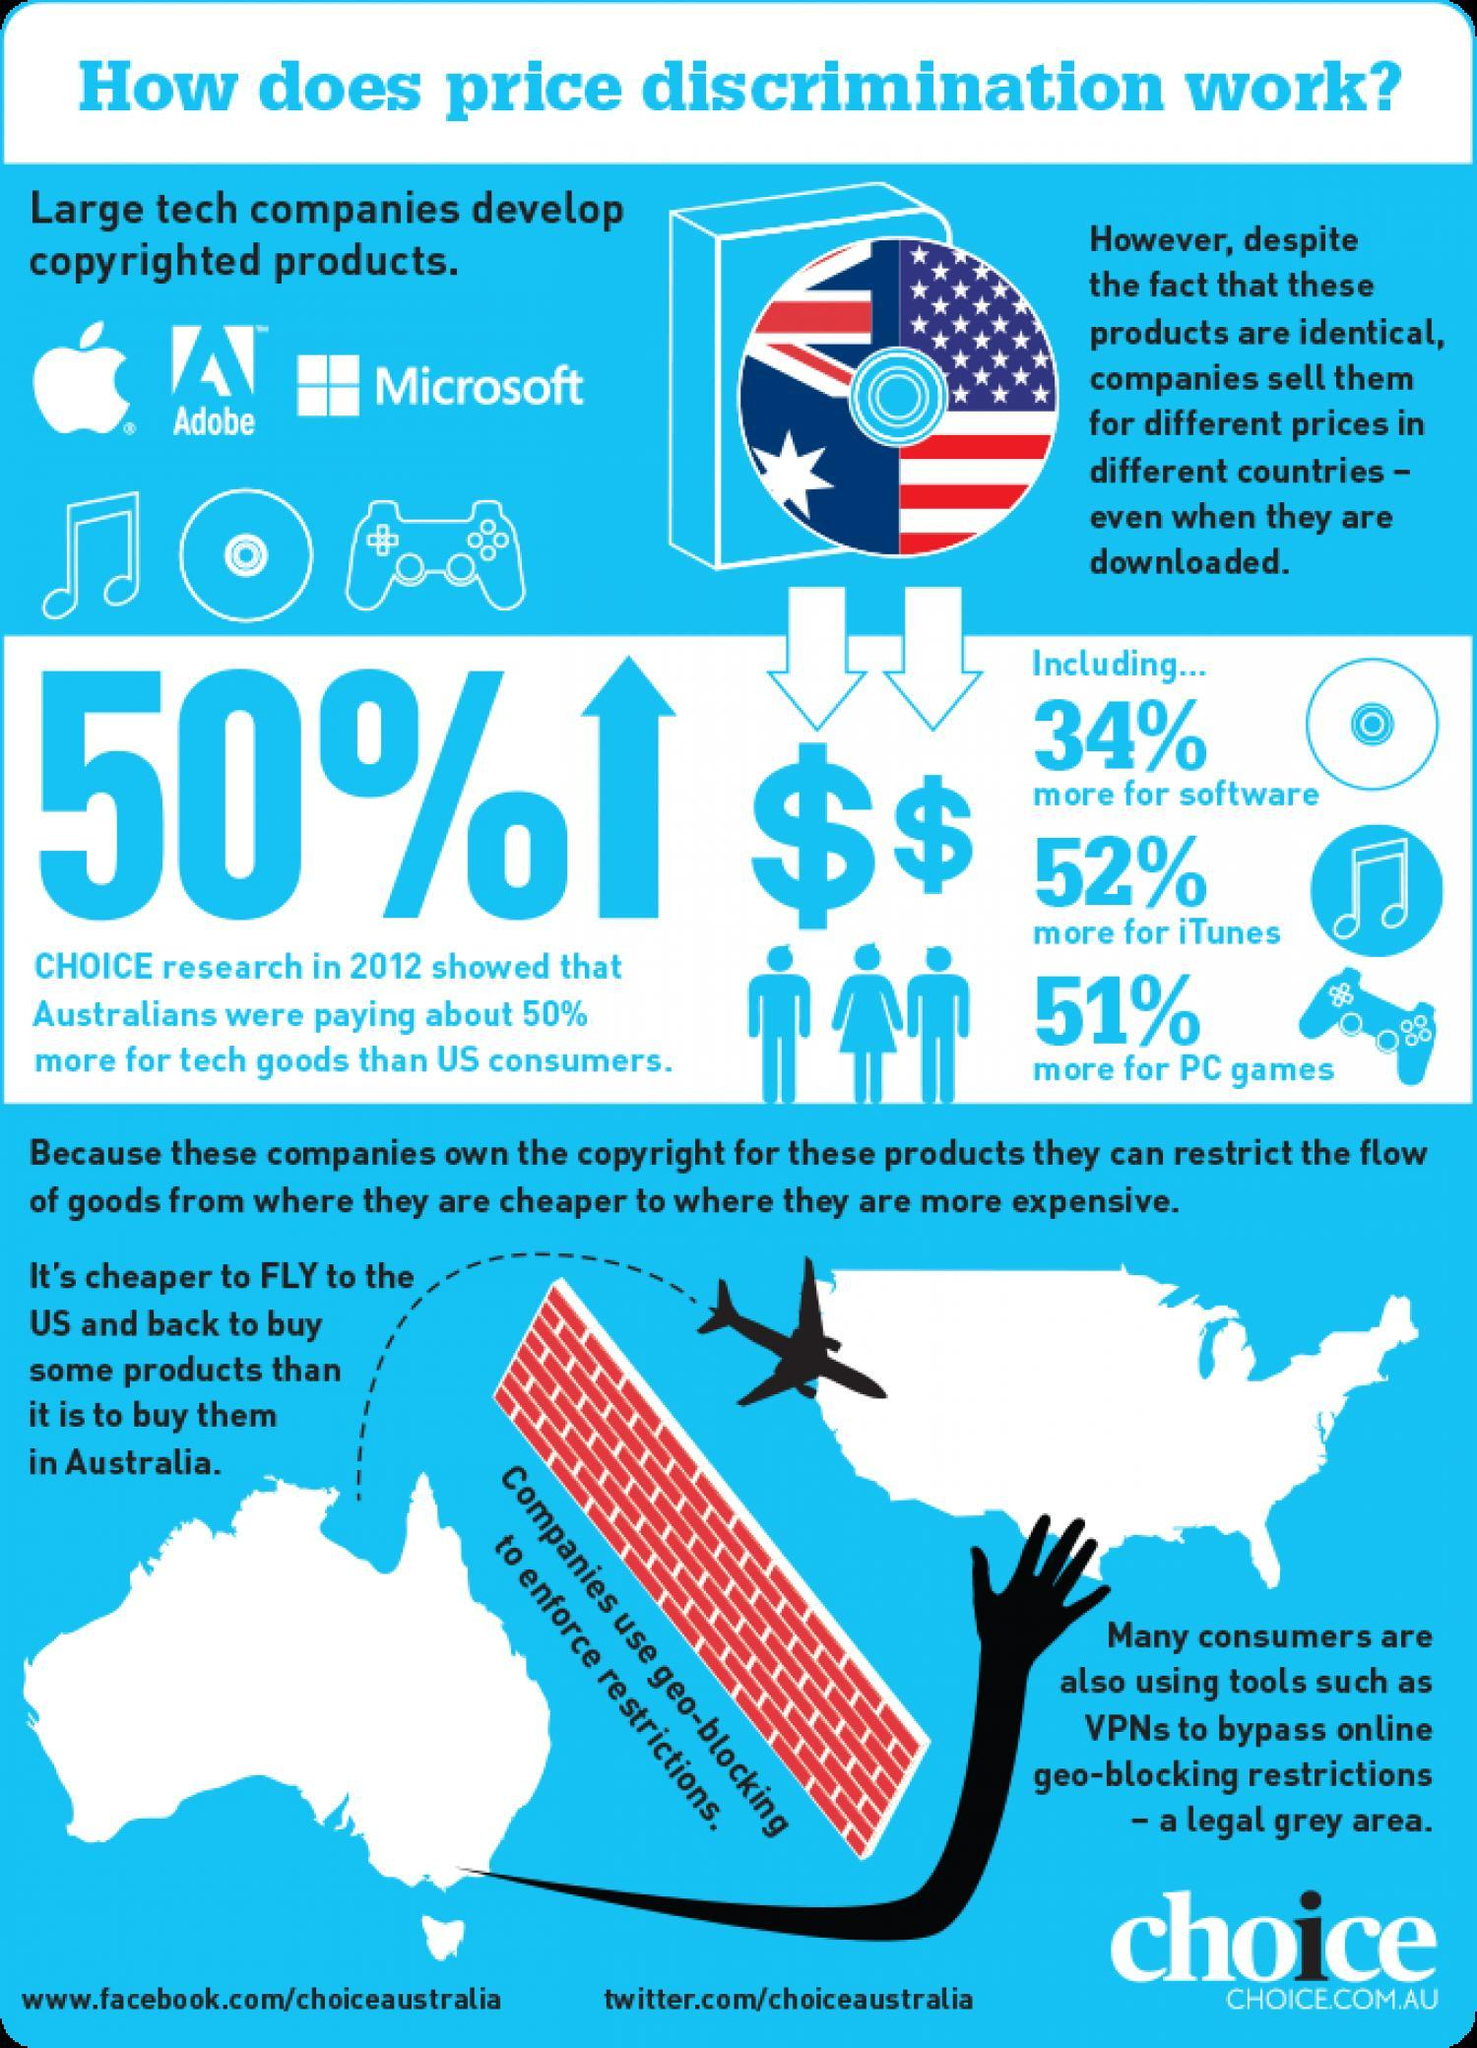Which technique is used to enforce restrictions?
Answer the question with a short phrase. geo-blocking 